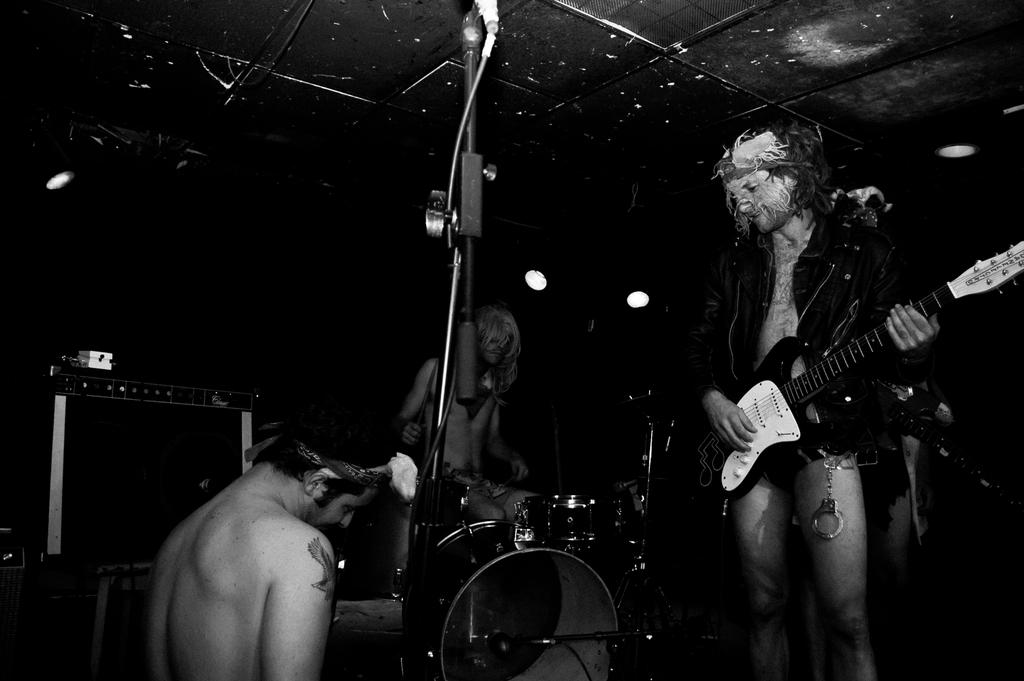What is the main subject of the image? There are two men in the image. What is the position of the man in the middle of the image? The man in the middle of the image is sitting. What is the standing man doing in the image? The standing man is playing the guitar. What type of banana is the man in the middle eating in the image? There is no banana present in the image, and the man in the middle is sitting, not eating. 